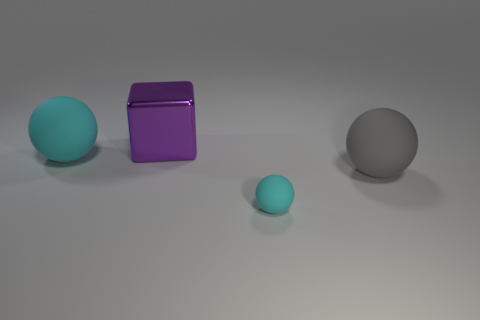What is the material of the other thing that is the same color as the tiny object?
Your response must be concise. Rubber. What is the size of the ball to the right of the cyan matte sphere in front of the matte object that is right of the small rubber object?
Make the answer very short. Large. Is the number of rubber objects that are behind the gray ball greater than the number of large gray objects that are in front of the small thing?
Your answer should be compact. Yes. How many matte objects are to the right of the cyan matte sphere that is to the left of the small cyan matte sphere?
Your response must be concise. 2. Is there another metallic thing of the same color as the metallic thing?
Ensure brevity in your answer.  No. Do the shiny thing and the gray sphere have the same size?
Offer a very short reply. Yes. There is a object that is behind the big rubber sphere to the left of the large gray object; what is it made of?
Give a very brief answer. Metal. What is the material of the large cyan object that is the same shape as the gray matte object?
Give a very brief answer. Rubber. Do the cyan ball that is left of the purple cube and the big gray ball have the same size?
Your answer should be very brief. Yes. How many matte objects are big cyan cylinders or cyan spheres?
Offer a terse response. 2. 